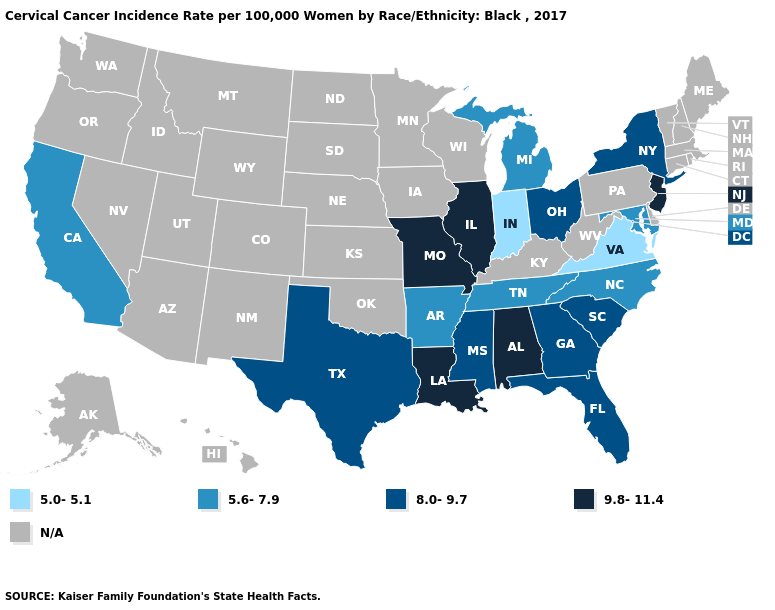Among the states that border Virginia , which have the highest value?
Keep it brief. Maryland, North Carolina, Tennessee. Which states have the lowest value in the South?
Answer briefly. Virginia. Among the states that border South Carolina , which have the lowest value?
Answer briefly. North Carolina. Which states hav the highest value in the MidWest?
Keep it brief. Illinois, Missouri. Name the states that have a value in the range 9.8-11.4?
Write a very short answer. Alabama, Illinois, Louisiana, Missouri, New Jersey. Among the states that border Missouri , which have the highest value?
Answer briefly. Illinois. Name the states that have a value in the range 8.0-9.7?
Be succinct. Florida, Georgia, Mississippi, New York, Ohio, South Carolina, Texas. What is the value of Florida?
Give a very brief answer. 8.0-9.7. Does New Jersey have the lowest value in the Northeast?
Keep it brief. No. What is the value of Utah?
Quick response, please. N/A. Among the states that border Georgia , does Alabama have the highest value?
Write a very short answer. Yes. What is the value of Iowa?
Be succinct. N/A. Among the states that border West Virginia , which have the highest value?
Answer briefly. Ohio. 